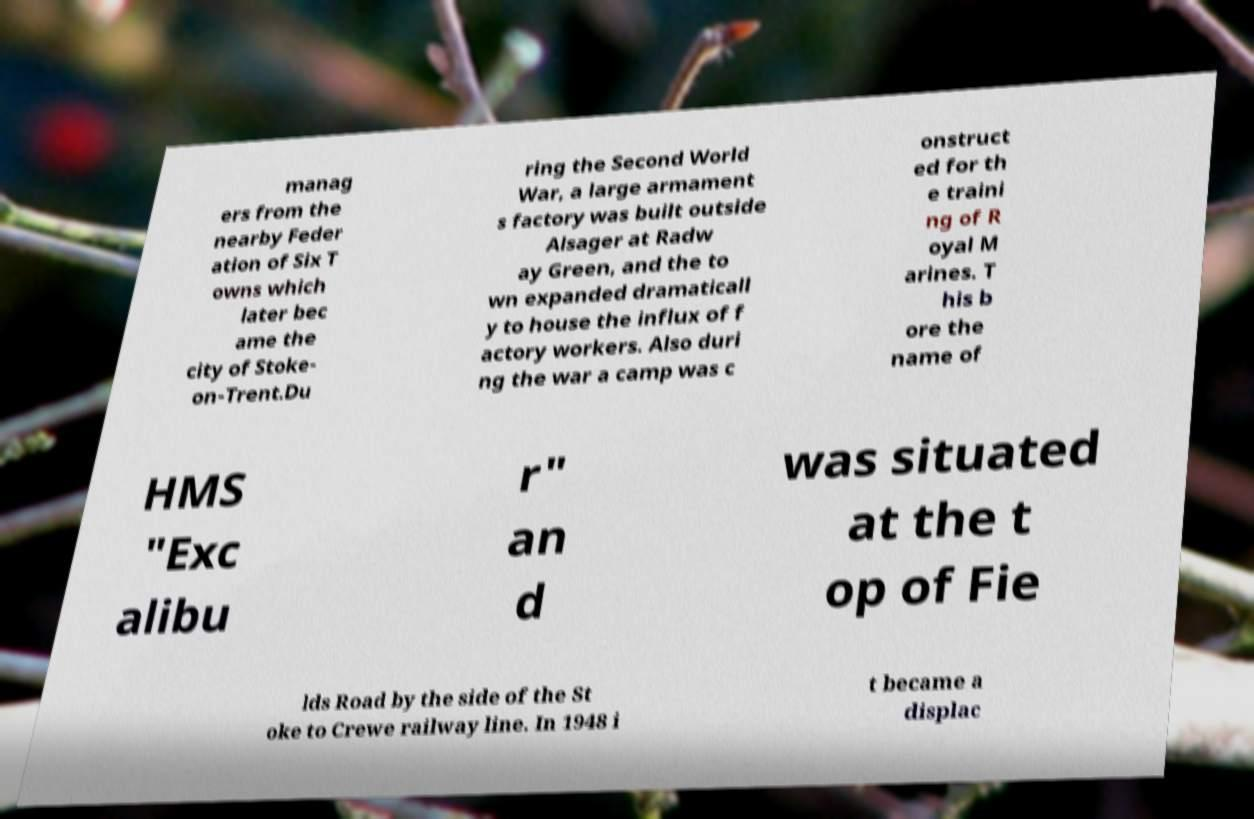I need the written content from this picture converted into text. Can you do that? manag ers from the nearby Feder ation of Six T owns which later bec ame the city of Stoke- on-Trent.Du ring the Second World War, a large armament s factory was built outside Alsager at Radw ay Green, and the to wn expanded dramaticall y to house the influx of f actory workers. Also duri ng the war a camp was c onstruct ed for th e traini ng of R oyal M arines. T his b ore the name of HMS "Exc alibu r" an d was situated at the t op of Fie lds Road by the side of the St oke to Crewe railway line. In 1948 i t became a displac 